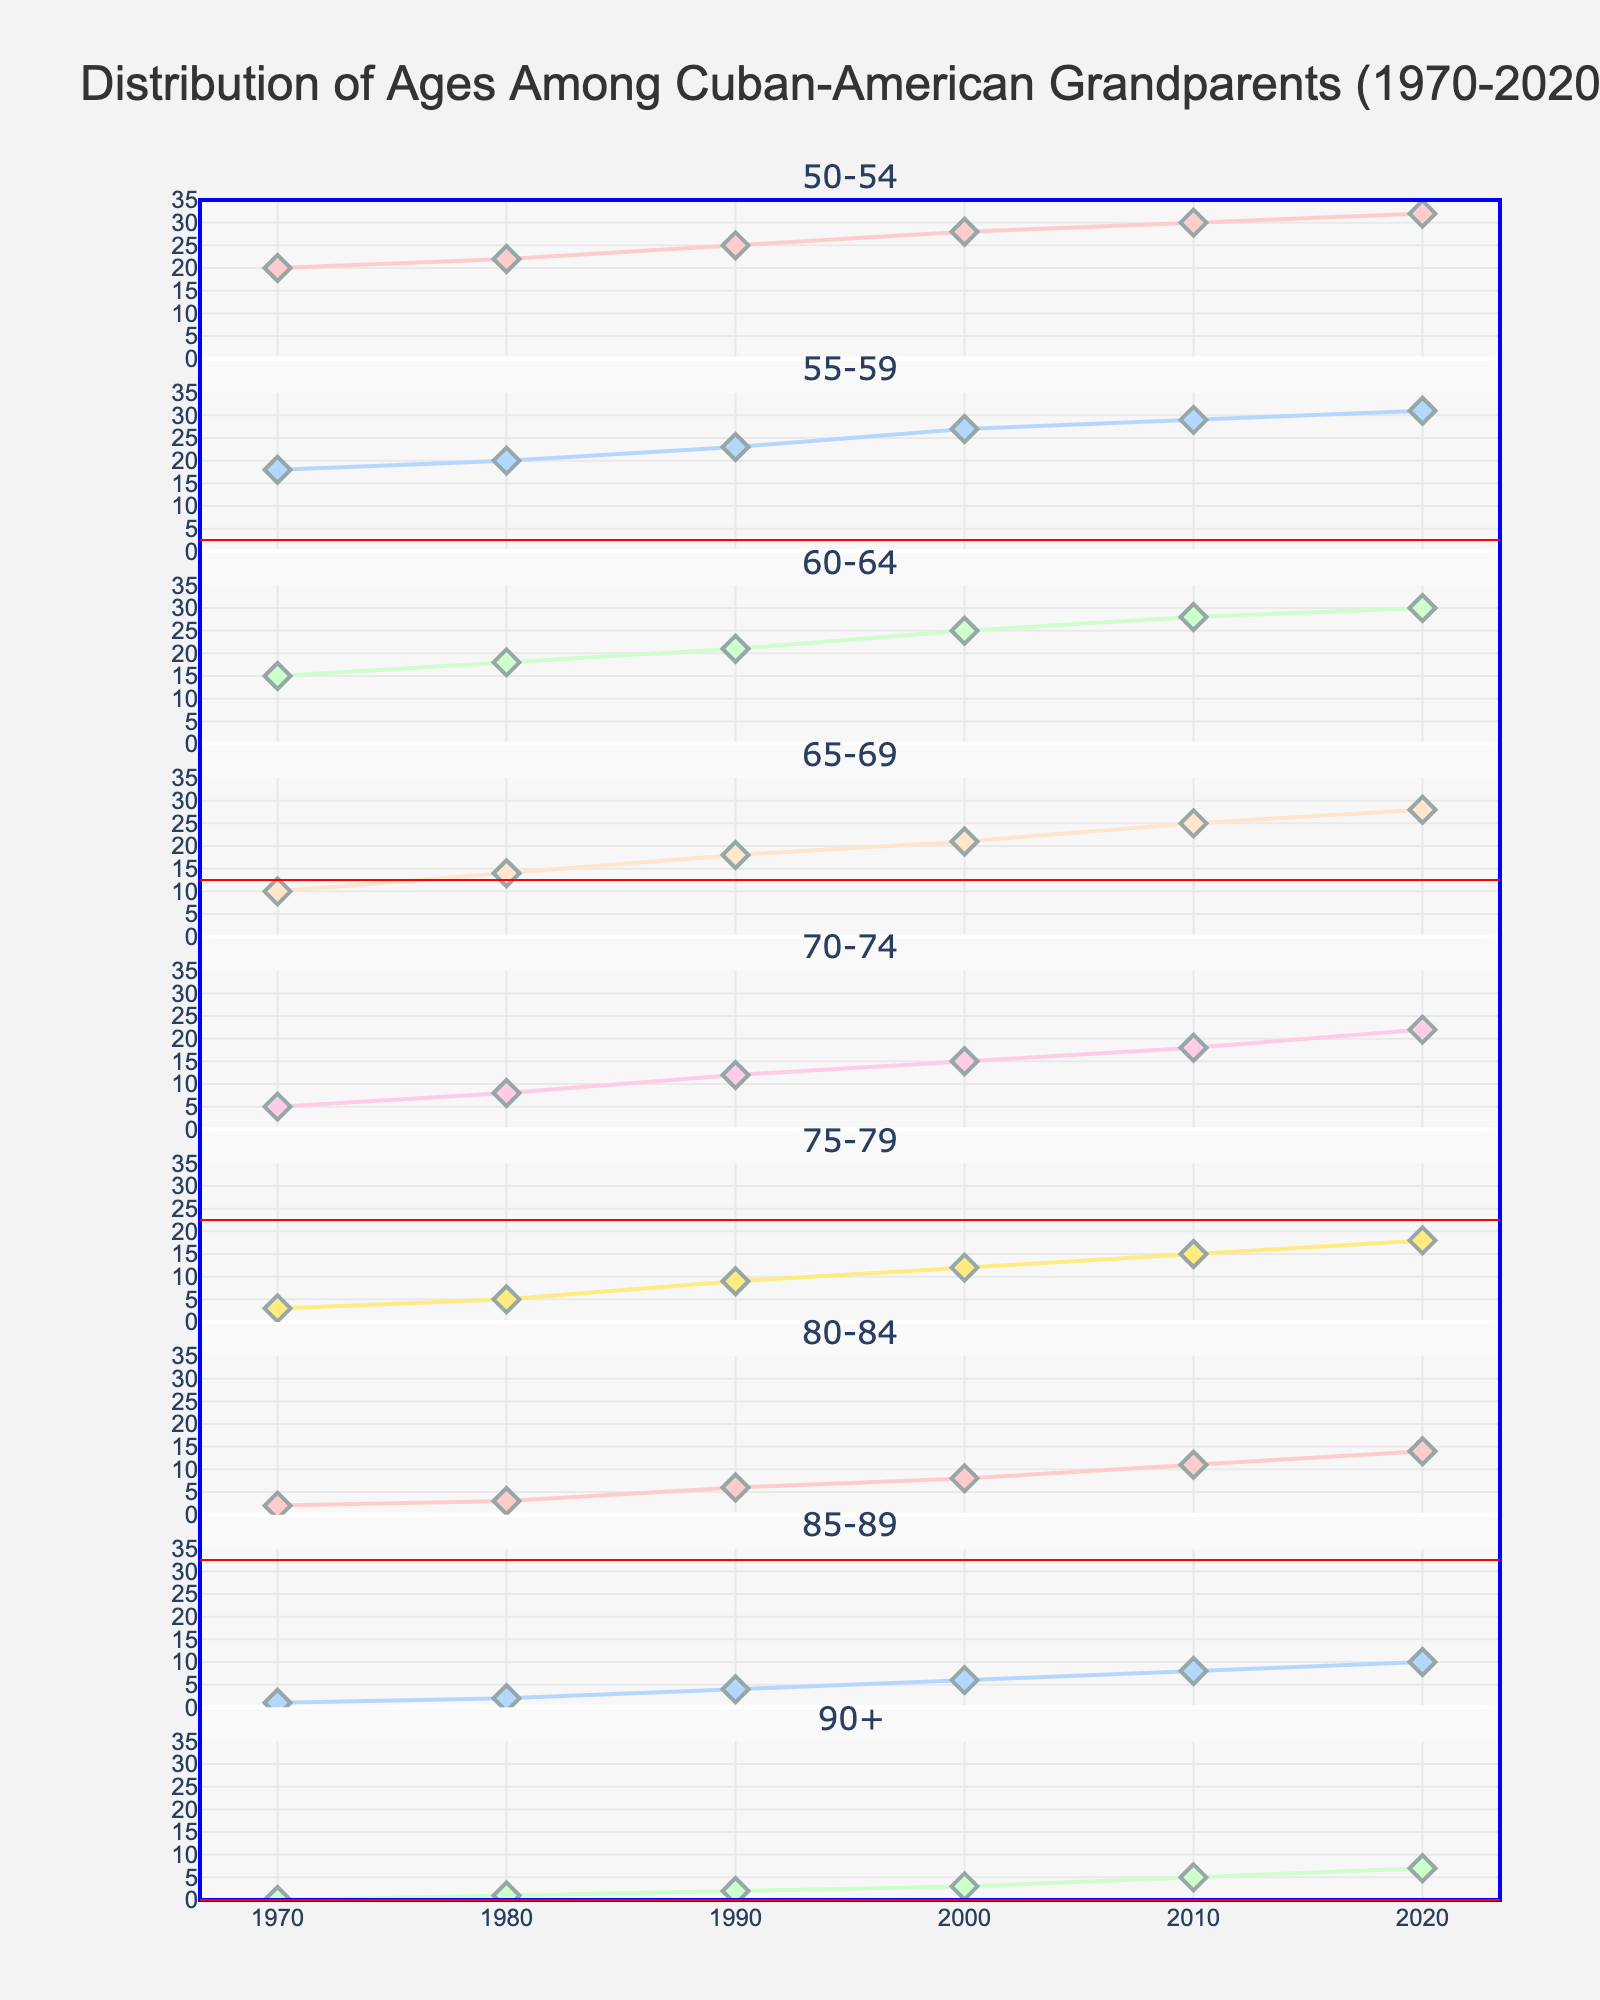What is the title of the graph? The title is displayed at the top of the graph. Read it to identify the exact wording.
Answer: Distribution of Ages Among Cuban-American Grandparents (1970-2020) How many years are displayed on the x-axis? Count the number of unique years shown along the x-axis.
Answer: 6 Which age range had the highest number of Cuban-American grandparents in 2020? Look at the values for each age range in 2020. Identify the highest value and the corresponding age range.
Answer: 50-54 Which age range had the greatest increase in the number of Cuban-American grandparents from 1970 to 2020? Calculate the difference between the 2020 and 1970 values for each age range. The age range with the largest difference is the answer.
Answer: 80-84 What is the average number of Cuban-American grandparents in the age range 60-64 over the past 50 years? Add the numbers for 60-64 from each year and divide by the number of years (6). (15 + 18 + 21 + 25 + 28 + 30) / 6 = 22.833
Answer: 22.833 Which two age ranges had the same number of Cuban-American grandparents in the year 2000? Compare the 2000 values for each age range. Identify any two age ranges with equal values.
Answer: 75-79 and 80-84 In which decade did the number of Cuban-American grandparents aged 65-69 surpass those aged 60-64? Compare the values of age ranges 65-69 and 60-64 for each decade. Identify the first decade where 65-69 value is greater than 60-64.
Answer: 2010s What is the median number of Cuban-American grandparents in the age range 70-74 over the past 50 years? Arrange the 70-74 values in ascending order and find the middle value. If there is an even number of values, average the two middle ones. Values are (5, 8, 12, 15, 18, 22). Median is (12 + 15) / 2 = 13.5
Answer: 13.5 Which age range had the least number of Cuban-American grandparents in 1990, and what was that number? Identify the smallest value in the 1990 column and the corresponding age range.
Answer: 90+, 2 